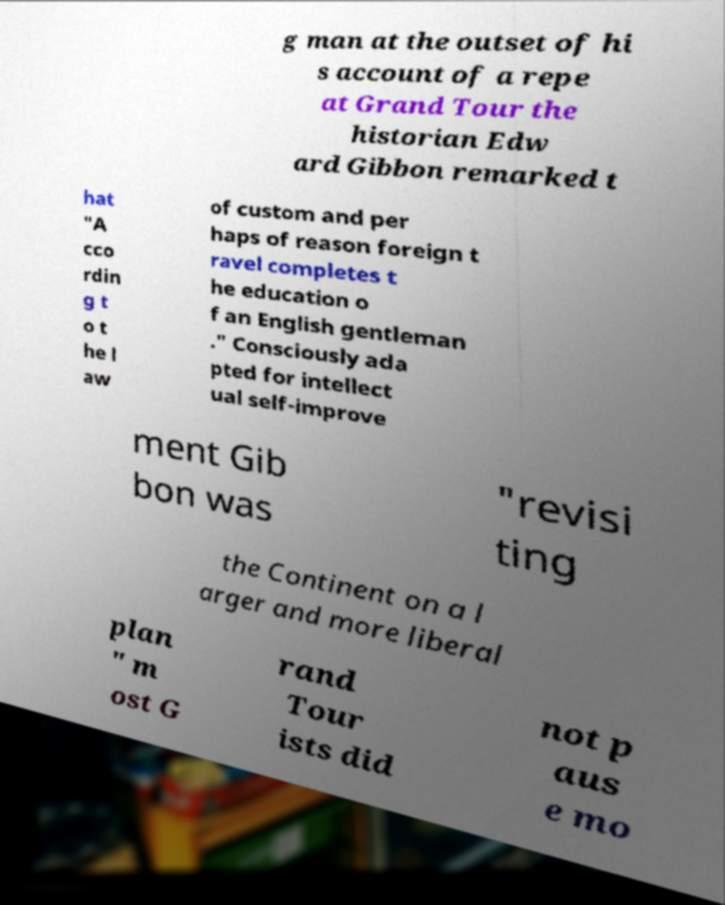Please identify and transcribe the text found in this image. g man at the outset of hi s account of a repe at Grand Tour the historian Edw ard Gibbon remarked t hat "A cco rdin g t o t he l aw of custom and per haps of reason foreign t ravel completes t he education o f an English gentleman ." Consciously ada pted for intellect ual self-improve ment Gib bon was "revisi ting the Continent on a l arger and more liberal plan " m ost G rand Tour ists did not p aus e mo 